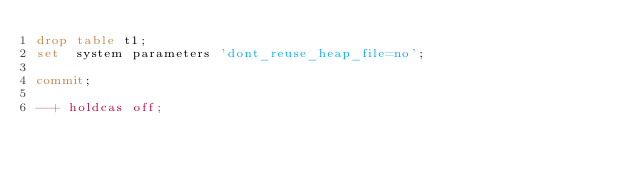Convert code to text. <code><loc_0><loc_0><loc_500><loc_500><_SQL_>drop table t1;
set  system parameters 'dont_reuse_heap_file=no';

commit;

--+ holdcas off;

</code> 